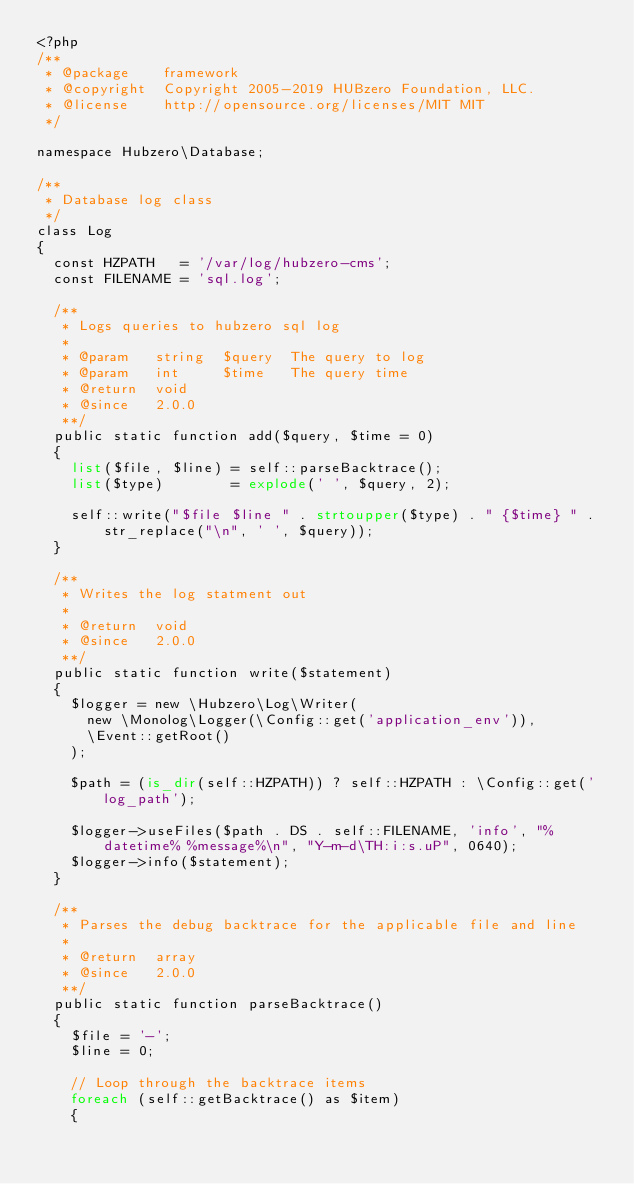Convert code to text. <code><loc_0><loc_0><loc_500><loc_500><_PHP_><?php
/**
 * @package    framework
 * @copyright  Copyright 2005-2019 HUBzero Foundation, LLC.
 * @license    http://opensource.org/licenses/MIT MIT
 */

namespace Hubzero\Database;

/**
 * Database log class
 */
class Log
{
	const HZPATH   = '/var/log/hubzero-cms';
	const FILENAME = 'sql.log';

	/**
	 * Logs queries to hubzero sql log
	 *
	 * @param   string  $query  The query to log
	 * @param   int     $time   The query time
	 * @return  void
	 * @since   2.0.0
	 **/
	public static function add($query, $time = 0)
	{
		list($file, $line) = self::parseBacktrace();
		list($type)        = explode(' ', $query, 2);

		self::write("$file $line " . strtoupper($type) . " {$time} " . str_replace("\n", ' ', $query));
	}

	/**
	 * Writes the log statment out
	 *
	 * @return  void
	 * @since   2.0.0
	 **/
	public static function write($statement)
	{
		$logger = new \Hubzero\Log\Writer(
			new \Monolog\Logger(\Config::get('application_env')),
			\Event::getRoot()
		);

		$path = (is_dir(self::HZPATH)) ? self::HZPATH : \Config::get('log_path');

		$logger->useFiles($path . DS . self::FILENAME, 'info', "%datetime% %message%\n", "Y-m-d\TH:i:s.uP", 0640);
		$logger->info($statement);
	}

	/**
	 * Parses the debug backtrace for the applicable file and line
	 *
	 * @return  array
	 * @since   2.0.0
	 **/
	public static function parseBacktrace()
	{
		$file = '-';
		$line = 0;

		// Loop through the backtrace items
		foreach (self::getBacktrace() as $item)
		{</code> 